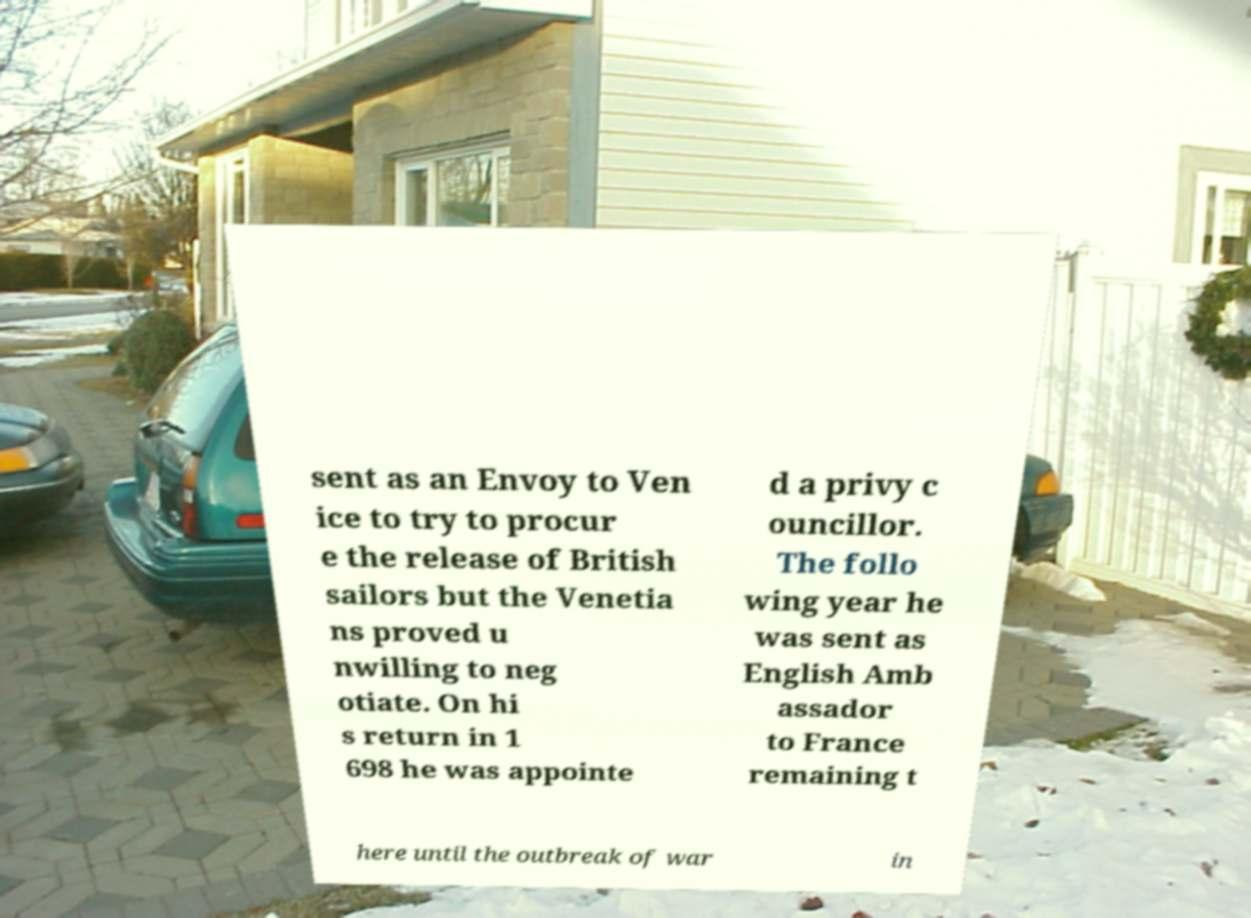For documentation purposes, I need the text within this image transcribed. Could you provide that? sent as an Envoy to Ven ice to try to procur e the release of British sailors but the Venetia ns proved u nwilling to neg otiate. On hi s return in 1 698 he was appointe d a privy c ouncillor. The follo wing year he was sent as English Amb assador to France remaining t here until the outbreak of war in 